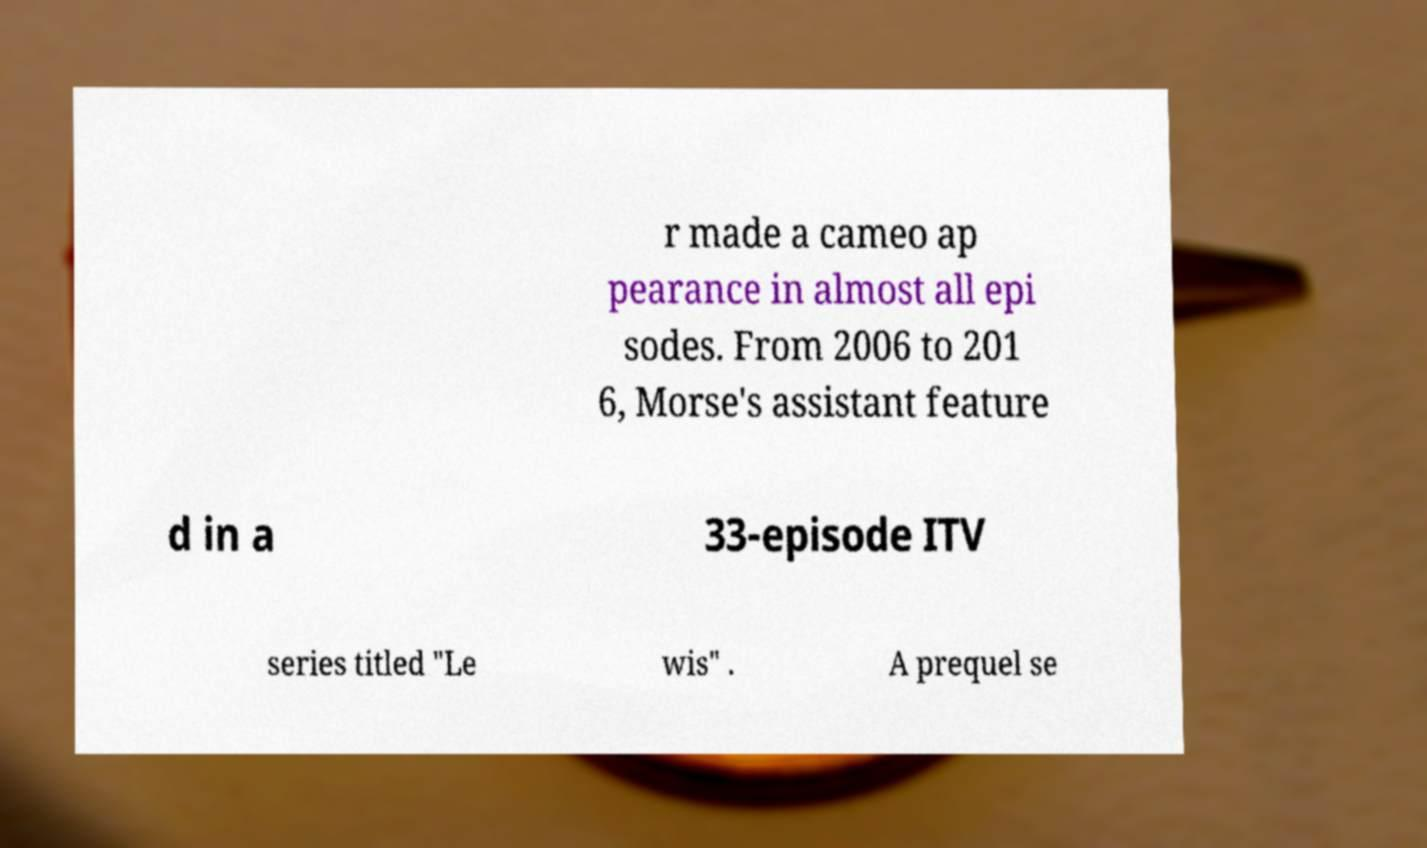What messages or text are displayed in this image? I need them in a readable, typed format. r made a cameo ap pearance in almost all epi sodes. From 2006 to 201 6, Morse's assistant feature d in a 33-episode ITV series titled "Le wis" . A prequel se 